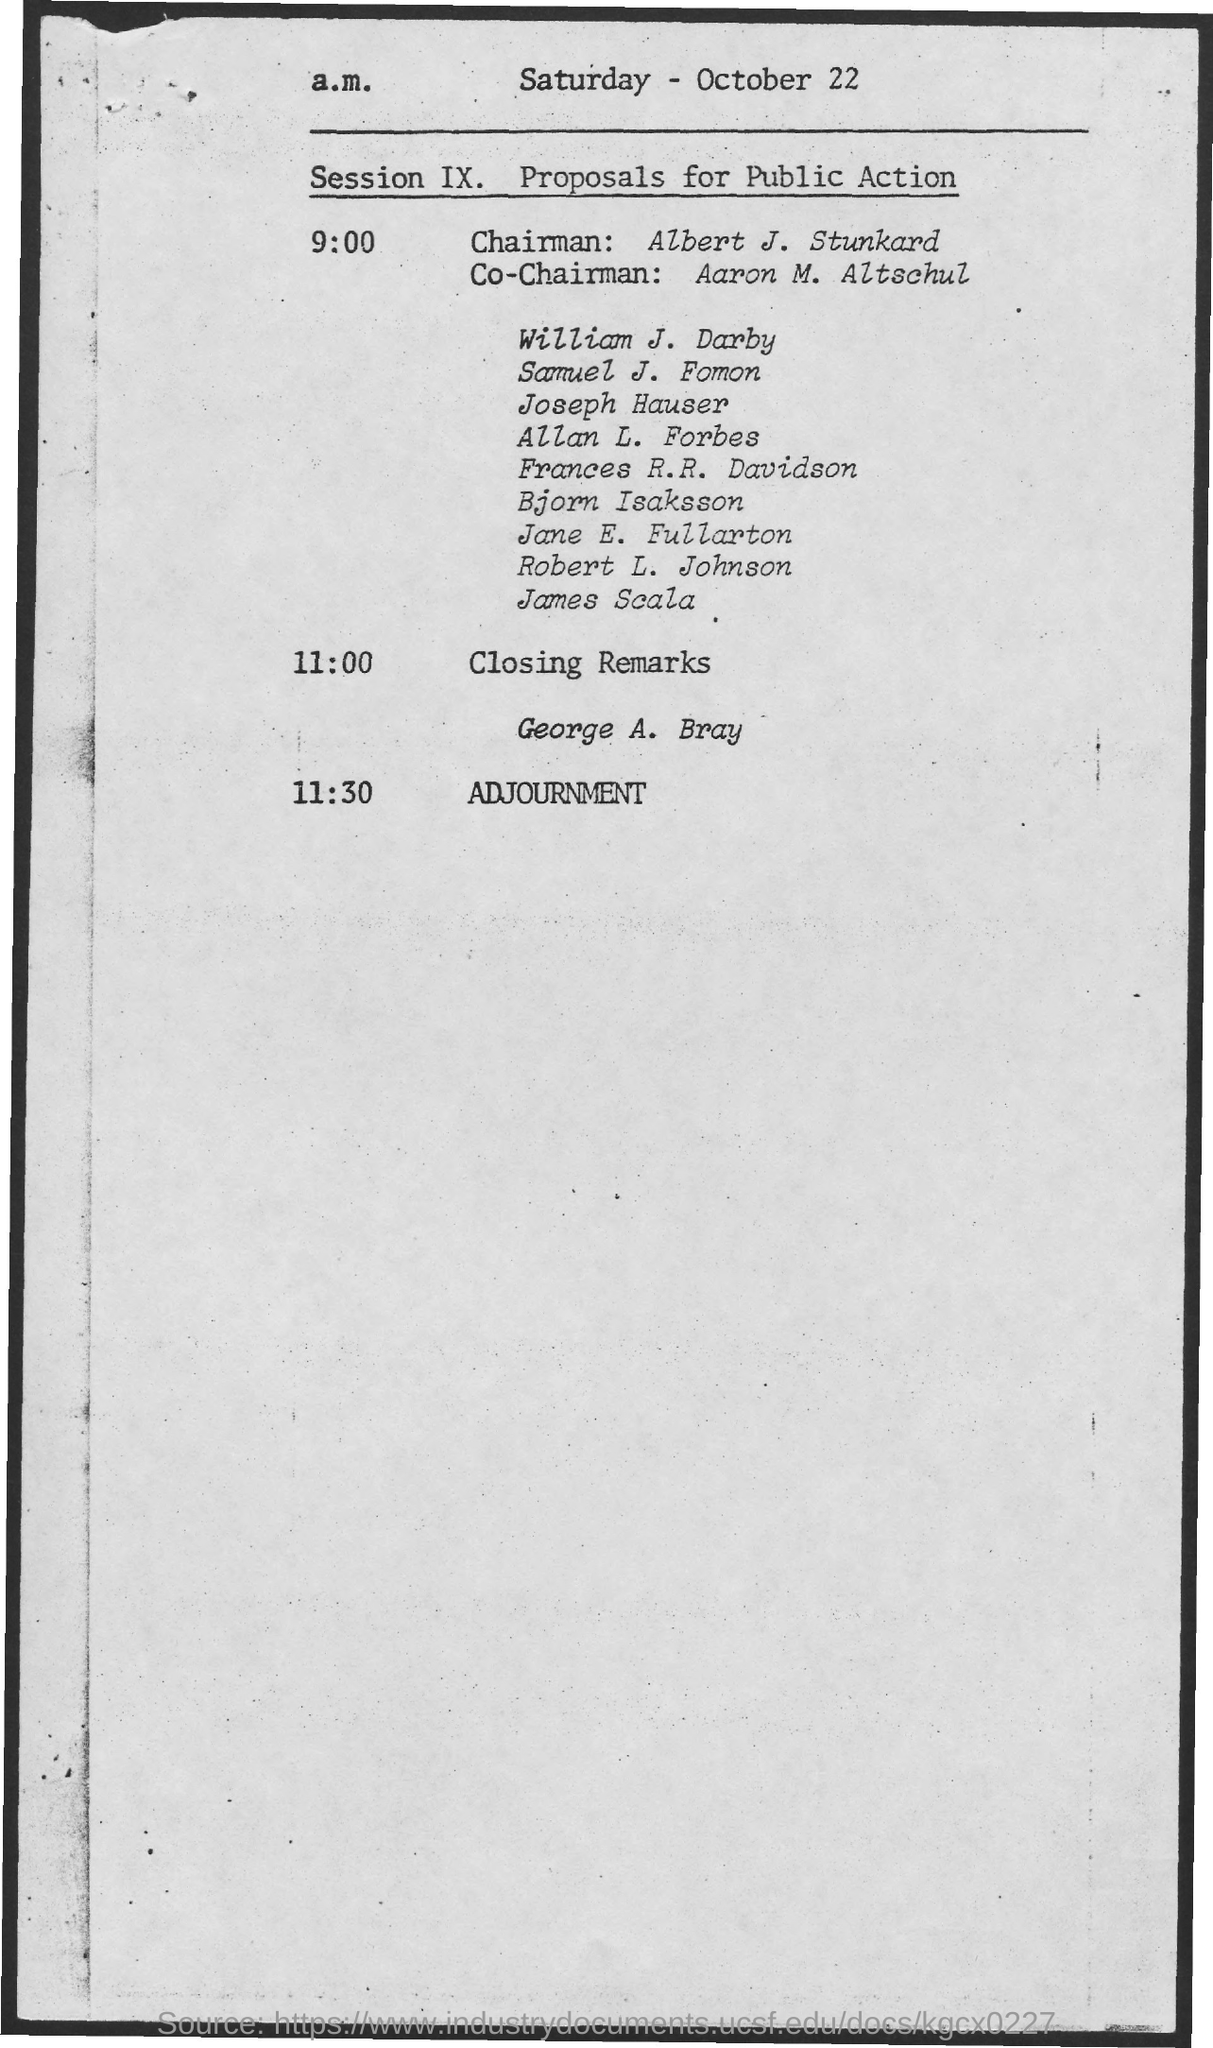Who is the chairman ?
Give a very brief answer. Albert J. Stunkard. Who is the co-chairman?
Your response must be concise. Aaron M. Altschul. What is session ix about?
Make the answer very short. Proposals for Public Action. What day of the week is mentioned in the document?
Your response must be concise. Saturday. Who is giving closing remarks?
Ensure brevity in your answer.  George A. Bray. What is time scheduled for adjournment?
Provide a short and direct response. 11.30. What is the month mentioned in the document?
Your answer should be very brief. October. 